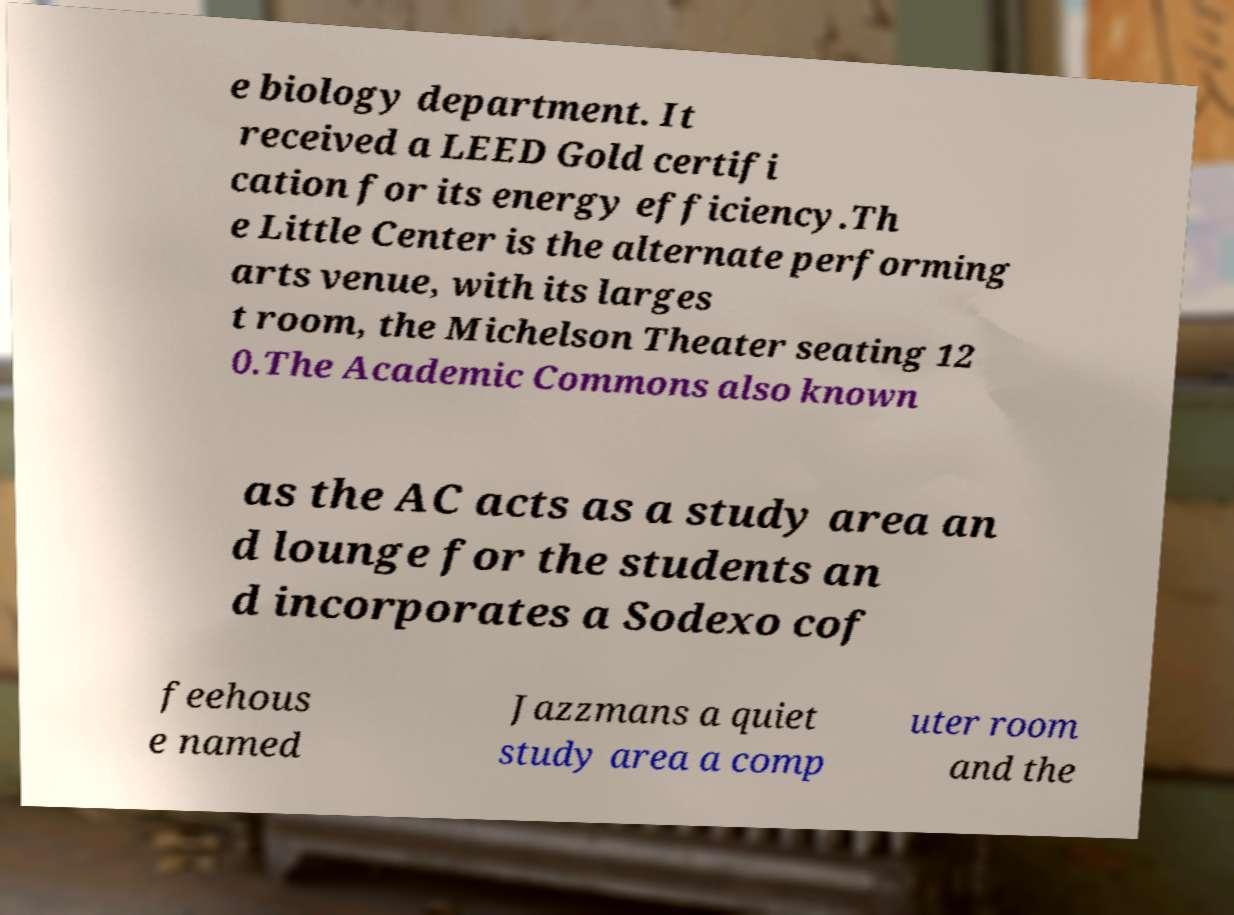I need the written content from this picture converted into text. Can you do that? e biology department. It received a LEED Gold certifi cation for its energy efficiency.Th e Little Center is the alternate performing arts venue, with its larges t room, the Michelson Theater seating 12 0.The Academic Commons also known as the AC acts as a study area an d lounge for the students an d incorporates a Sodexo cof feehous e named Jazzmans a quiet study area a comp uter room and the 